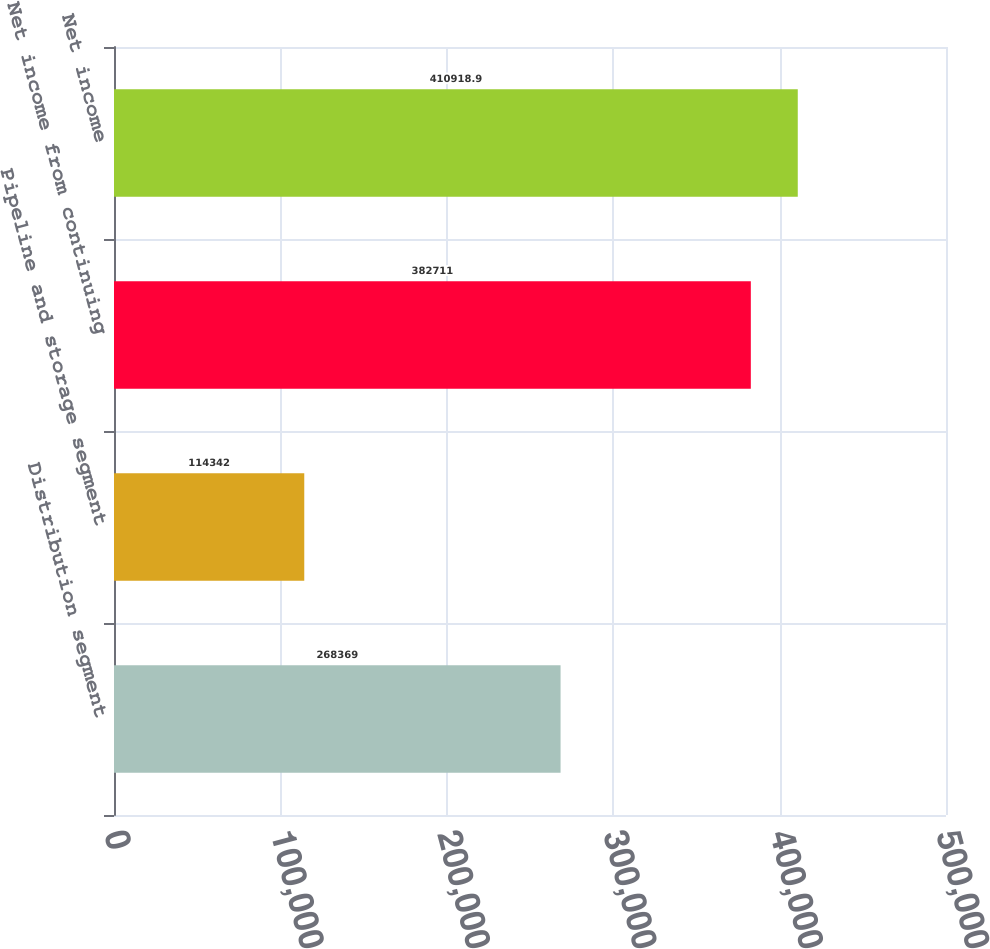<chart> <loc_0><loc_0><loc_500><loc_500><bar_chart><fcel>Distribution segment<fcel>Pipeline and storage segment<fcel>Net income from continuing<fcel>Net income<nl><fcel>268369<fcel>114342<fcel>382711<fcel>410919<nl></chart> 